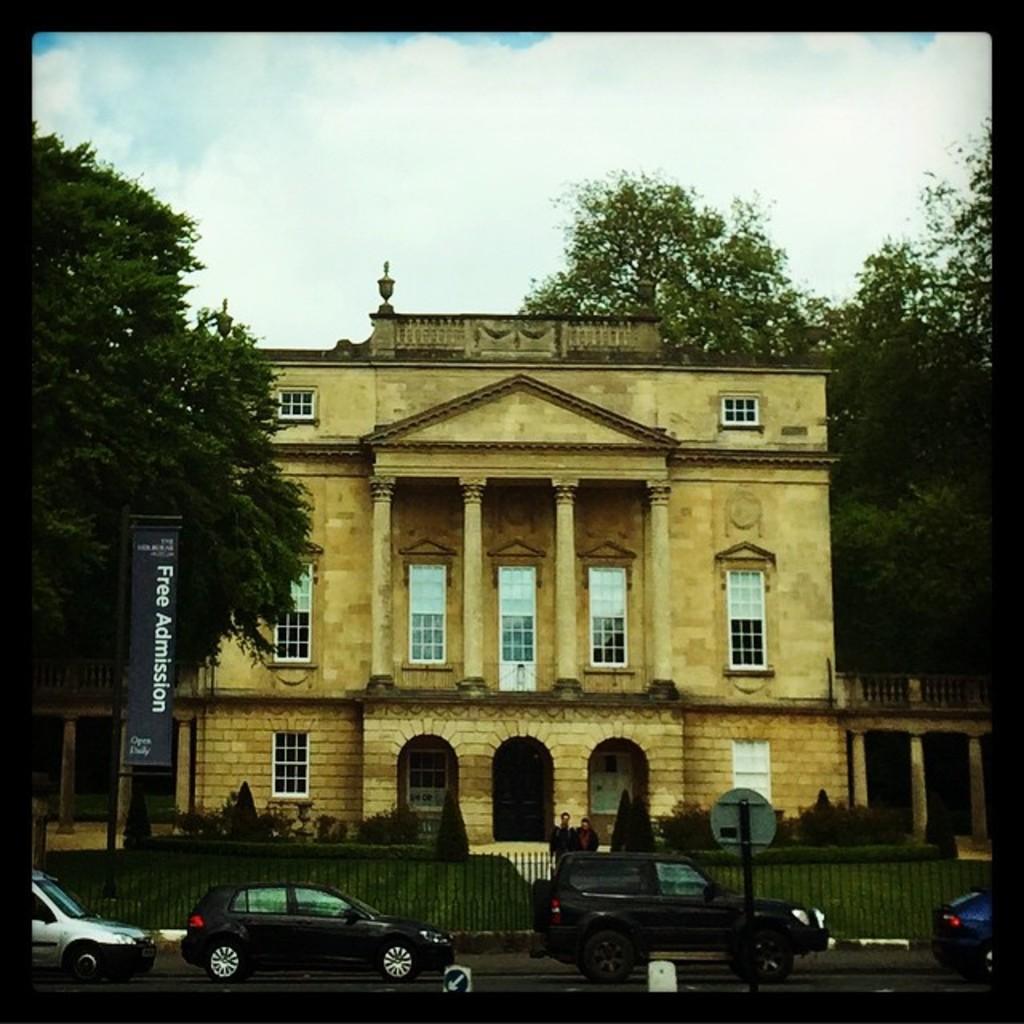Describe this image in one or two sentences. In this image there are few cars on the road. Behind it there is a fence. Two persons are standing behind the fence. There are few plants on the grassland. Behind there is a building. There are few trees. Top of image there is sky. 